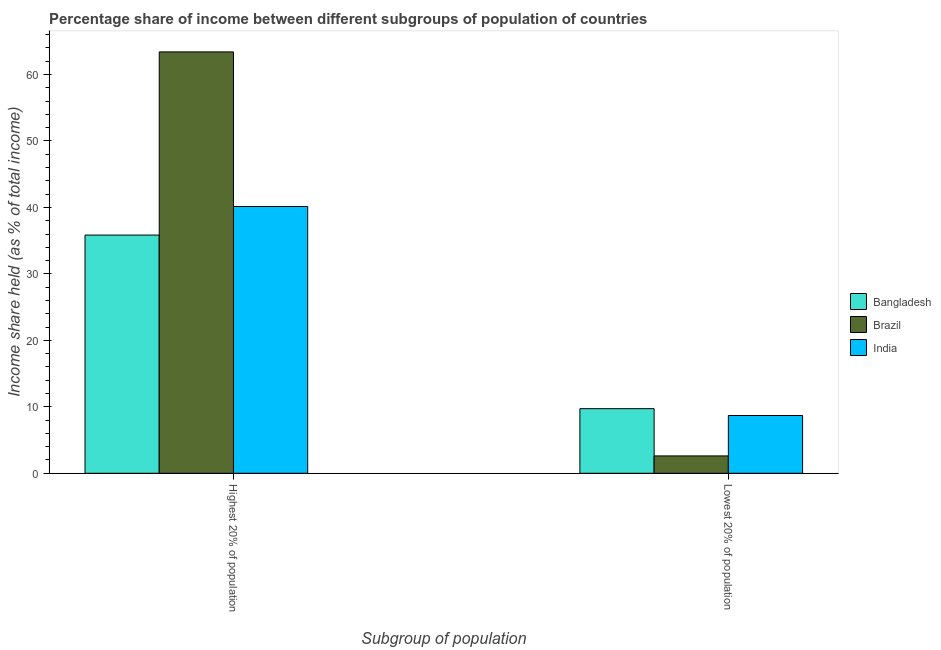How many bars are there on the 2nd tick from the left?
Make the answer very short. 3. How many bars are there on the 1st tick from the right?
Keep it short and to the point. 3. What is the label of the 1st group of bars from the left?
Your answer should be very brief. Highest 20% of population. What is the income share held by highest 20% of the population in Bangladesh?
Provide a succinct answer. 35.84. Across all countries, what is the maximum income share held by highest 20% of the population?
Keep it short and to the point. 63.4. Across all countries, what is the minimum income share held by lowest 20% of the population?
Offer a terse response. 2.61. In which country was the income share held by highest 20% of the population maximum?
Keep it short and to the point. Brazil. What is the total income share held by lowest 20% of the population in the graph?
Give a very brief answer. 21.02. What is the difference between the income share held by lowest 20% of the population in Bangladesh and that in Brazil?
Your answer should be compact. 7.11. What is the difference between the income share held by lowest 20% of the population in Brazil and the income share held by highest 20% of the population in Bangladesh?
Ensure brevity in your answer.  -33.23. What is the average income share held by lowest 20% of the population per country?
Your answer should be compact. 7.01. What is the difference between the income share held by highest 20% of the population and income share held by lowest 20% of the population in Brazil?
Ensure brevity in your answer.  60.79. What is the ratio of the income share held by lowest 20% of the population in Brazil to that in India?
Provide a short and direct response. 0.3. In how many countries, is the income share held by highest 20% of the population greater than the average income share held by highest 20% of the population taken over all countries?
Provide a short and direct response. 1. What does the 1st bar from the right in Lowest 20% of population represents?
Your response must be concise. India. Are all the bars in the graph horizontal?
Make the answer very short. No. How many countries are there in the graph?
Provide a short and direct response. 3. Are the values on the major ticks of Y-axis written in scientific E-notation?
Ensure brevity in your answer.  No. Does the graph contain any zero values?
Your answer should be compact. No. How many legend labels are there?
Provide a succinct answer. 3. What is the title of the graph?
Keep it short and to the point. Percentage share of income between different subgroups of population of countries. What is the label or title of the X-axis?
Give a very brief answer. Subgroup of population. What is the label or title of the Y-axis?
Your response must be concise. Income share held (as % of total income). What is the Income share held (as % of total income) of Bangladesh in Highest 20% of population?
Make the answer very short. 35.84. What is the Income share held (as % of total income) in Brazil in Highest 20% of population?
Keep it short and to the point. 63.4. What is the Income share held (as % of total income) in India in Highest 20% of population?
Give a very brief answer. 40.14. What is the Income share held (as % of total income) in Bangladesh in Lowest 20% of population?
Make the answer very short. 9.72. What is the Income share held (as % of total income) in Brazil in Lowest 20% of population?
Provide a succinct answer. 2.61. What is the Income share held (as % of total income) in India in Lowest 20% of population?
Offer a very short reply. 8.69. Across all Subgroup of population, what is the maximum Income share held (as % of total income) of Bangladesh?
Offer a very short reply. 35.84. Across all Subgroup of population, what is the maximum Income share held (as % of total income) of Brazil?
Make the answer very short. 63.4. Across all Subgroup of population, what is the maximum Income share held (as % of total income) in India?
Make the answer very short. 40.14. Across all Subgroup of population, what is the minimum Income share held (as % of total income) in Bangladesh?
Offer a terse response. 9.72. Across all Subgroup of population, what is the minimum Income share held (as % of total income) of Brazil?
Your response must be concise. 2.61. Across all Subgroup of population, what is the minimum Income share held (as % of total income) of India?
Provide a short and direct response. 8.69. What is the total Income share held (as % of total income) of Bangladesh in the graph?
Your answer should be very brief. 45.56. What is the total Income share held (as % of total income) in Brazil in the graph?
Provide a succinct answer. 66.01. What is the total Income share held (as % of total income) of India in the graph?
Your response must be concise. 48.83. What is the difference between the Income share held (as % of total income) of Bangladesh in Highest 20% of population and that in Lowest 20% of population?
Your answer should be compact. 26.12. What is the difference between the Income share held (as % of total income) in Brazil in Highest 20% of population and that in Lowest 20% of population?
Make the answer very short. 60.79. What is the difference between the Income share held (as % of total income) in India in Highest 20% of population and that in Lowest 20% of population?
Your answer should be very brief. 31.45. What is the difference between the Income share held (as % of total income) in Bangladesh in Highest 20% of population and the Income share held (as % of total income) in Brazil in Lowest 20% of population?
Your answer should be very brief. 33.23. What is the difference between the Income share held (as % of total income) in Bangladesh in Highest 20% of population and the Income share held (as % of total income) in India in Lowest 20% of population?
Your answer should be compact. 27.15. What is the difference between the Income share held (as % of total income) of Brazil in Highest 20% of population and the Income share held (as % of total income) of India in Lowest 20% of population?
Ensure brevity in your answer.  54.71. What is the average Income share held (as % of total income) in Bangladesh per Subgroup of population?
Offer a terse response. 22.78. What is the average Income share held (as % of total income) of Brazil per Subgroup of population?
Your answer should be very brief. 33.01. What is the average Income share held (as % of total income) of India per Subgroup of population?
Offer a very short reply. 24.41. What is the difference between the Income share held (as % of total income) in Bangladesh and Income share held (as % of total income) in Brazil in Highest 20% of population?
Provide a short and direct response. -27.56. What is the difference between the Income share held (as % of total income) of Brazil and Income share held (as % of total income) of India in Highest 20% of population?
Offer a terse response. 23.26. What is the difference between the Income share held (as % of total income) of Bangladesh and Income share held (as % of total income) of Brazil in Lowest 20% of population?
Your answer should be very brief. 7.11. What is the difference between the Income share held (as % of total income) of Brazil and Income share held (as % of total income) of India in Lowest 20% of population?
Provide a short and direct response. -6.08. What is the ratio of the Income share held (as % of total income) in Bangladesh in Highest 20% of population to that in Lowest 20% of population?
Offer a very short reply. 3.69. What is the ratio of the Income share held (as % of total income) in Brazil in Highest 20% of population to that in Lowest 20% of population?
Provide a short and direct response. 24.29. What is the ratio of the Income share held (as % of total income) of India in Highest 20% of population to that in Lowest 20% of population?
Keep it short and to the point. 4.62. What is the difference between the highest and the second highest Income share held (as % of total income) of Bangladesh?
Provide a short and direct response. 26.12. What is the difference between the highest and the second highest Income share held (as % of total income) of Brazil?
Ensure brevity in your answer.  60.79. What is the difference between the highest and the second highest Income share held (as % of total income) in India?
Your response must be concise. 31.45. What is the difference between the highest and the lowest Income share held (as % of total income) of Bangladesh?
Provide a short and direct response. 26.12. What is the difference between the highest and the lowest Income share held (as % of total income) of Brazil?
Make the answer very short. 60.79. What is the difference between the highest and the lowest Income share held (as % of total income) in India?
Provide a short and direct response. 31.45. 